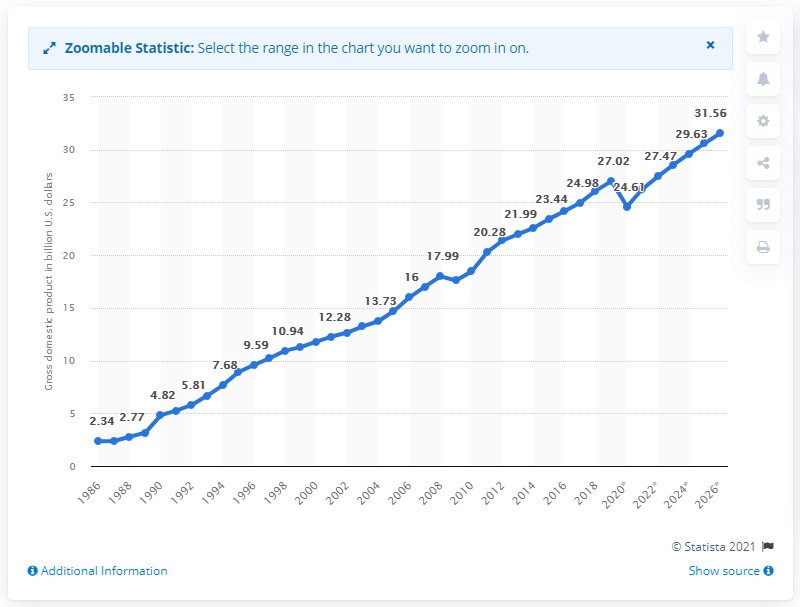Outline some significant characteristics in this image. In 2019, El Salvador's Gross Domestic Product was 27.02. 